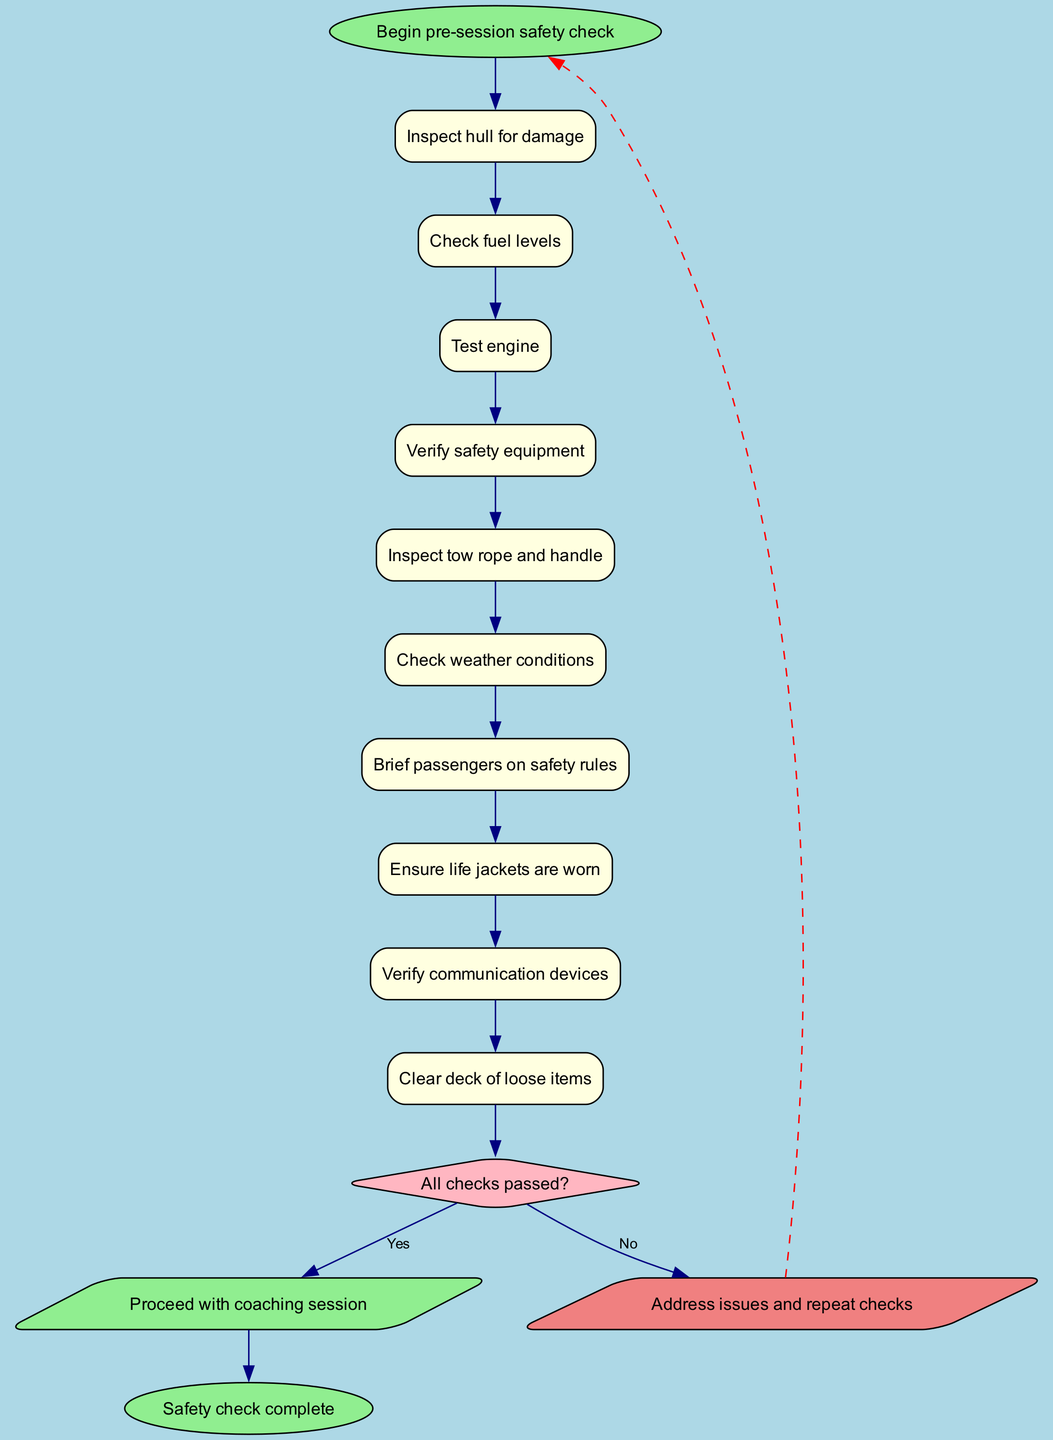What is the first step in the safety procedure? The diagram starts with the step labeled "Begin pre-session safety check," which indicates it is the initial action to take.
Answer: Begin pre-session safety check How many steps are included in the procedure? The diagram has a list of 10 steps, including the final decision point and the end conclusion.
Answer: 10 What is the decision point in the flow chart? The decision point is labeled "All checks passed?", which determines whether to proceed or address issues.
Answer: All checks passed? What happens if the checks do not pass? If the checks are not passed, the flow directs back to the start, indicating that the issues need to be addressed and checks repeated.
Answer: Address issues and repeat checks What is the last node of the flow chart? The final node is labeled "Safety check complete," indicating the conclusion of the process if all safety checks are satisfactory.
Answer: Safety check complete Which step involves checking weather conditions? The specific step on the diagram labeled "Check weather conditions" corresponds to assessing external safety factors before proceeding.
Answer: Check weather conditions What shape is used for the decision node? The decision node is represented in the diagram with a diamond shape, which typically signifies a decision-making point in a flowchart.
Answer: Diamond How are the emotional tones of the 'yes' and 'no' responses represented? The 'yes' response is in light green, while the 'no' response is in light coral, visually indicating positive and negative outcomes respectively.
Answer: Light green, light coral What safety rule is repeated for passengers? The instruction "Brief passengers on safety rules" indicates the necessity to ensure all passengers are aware of safety protocols before the session starts.
Answer: Brief passengers on safety rules 